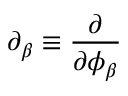Convert formula to latex. <formula><loc_0><loc_0><loc_500><loc_500>\partial _ { \beta } \equiv \frac { \partial } { \partial \phi _ { \beta } }</formula> 